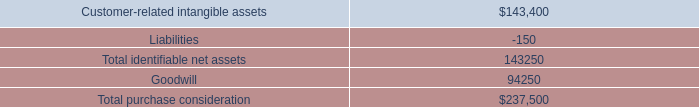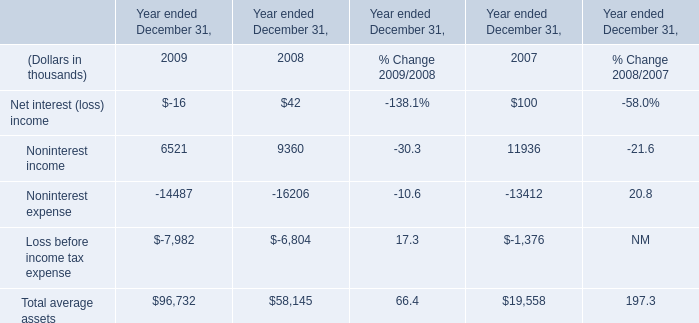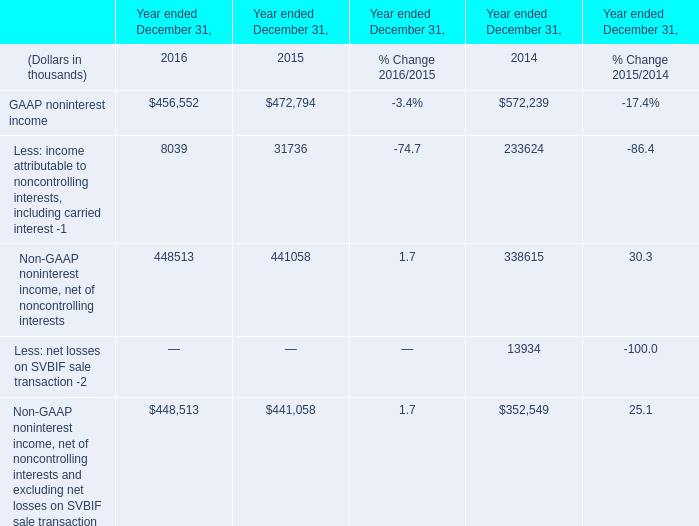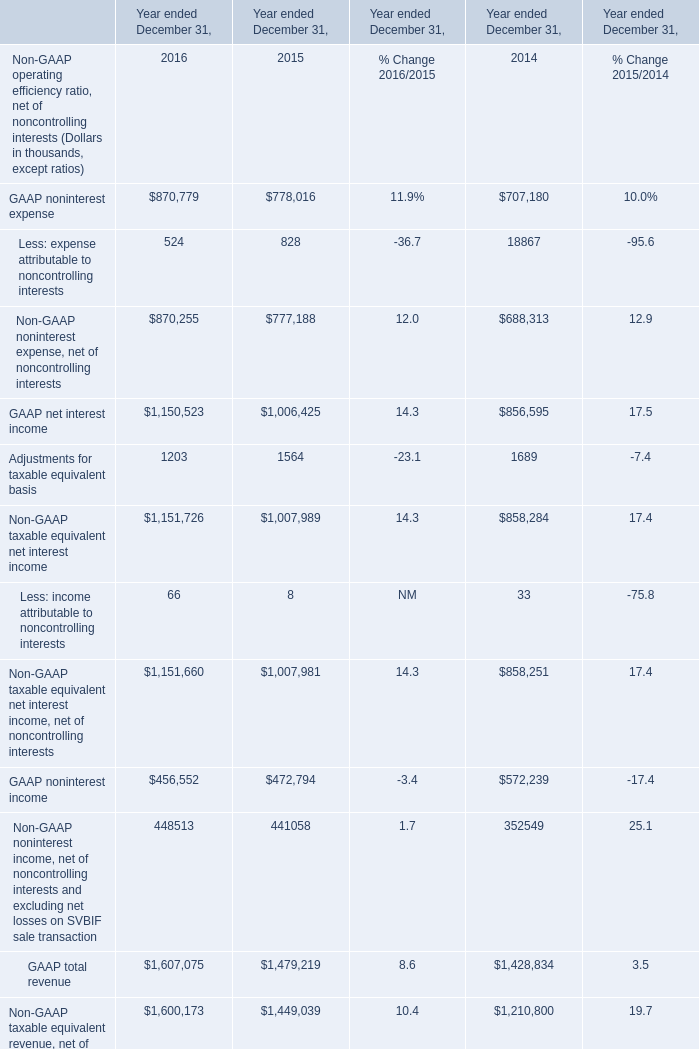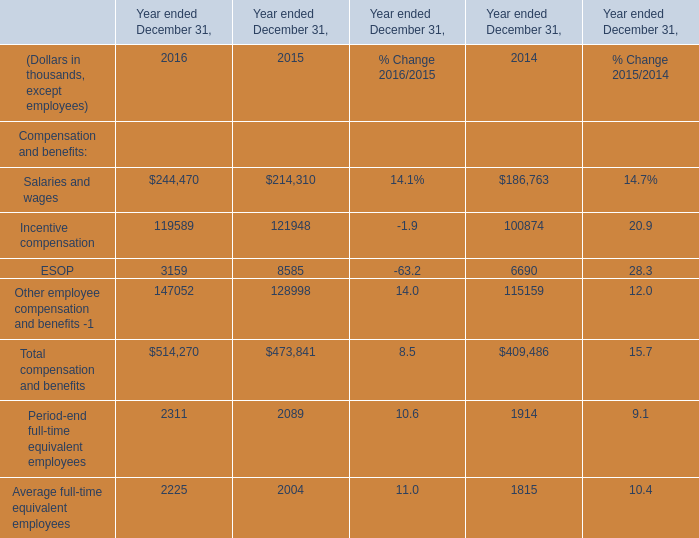What is the total amount of GAAP noninterest income of Year ended December 31, 2015, Salaries and wages of Year ended December 31, 2014, and GAAP total revenue of Year ended December 31, 2015 ? 
Computations: ((472794.0 + 186763.0) + 1479219.0)
Answer: 2138776.0. 